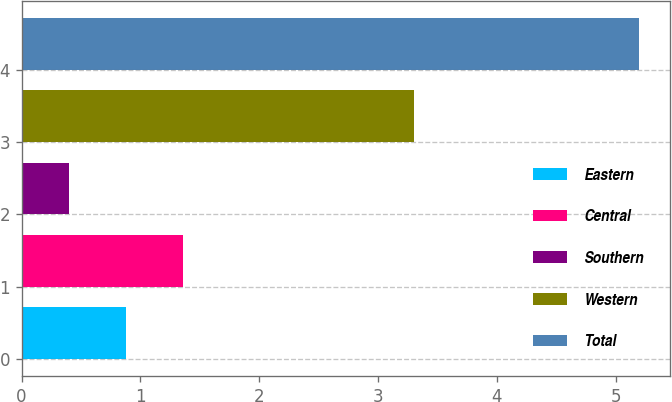Convert chart. <chart><loc_0><loc_0><loc_500><loc_500><bar_chart><fcel>Eastern<fcel>Central<fcel>Southern<fcel>Western<fcel>Total<nl><fcel>0.88<fcel>1.36<fcel>0.4<fcel>3.3<fcel>5.2<nl></chart> 